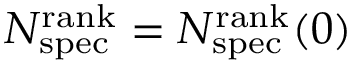Convert formula to latex. <formula><loc_0><loc_0><loc_500><loc_500>N _ { s p e c } ^ { r a n k } = N _ { s p e c } ^ { r a n k } ( 0 )</formula> 